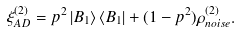<formula> <loc_0><loc_0><loc_500><loc_500>\xi ^ { ( 2 ) } _ { A D } = p ^ { 2 } \left | B _ { 1 } \right \rangle \left \langle B _ { 1 } \right | + ( 1 - p ^ { 2 } ) \rho _ { n o i s e } ^ { ( 2 ) } .</formula> 